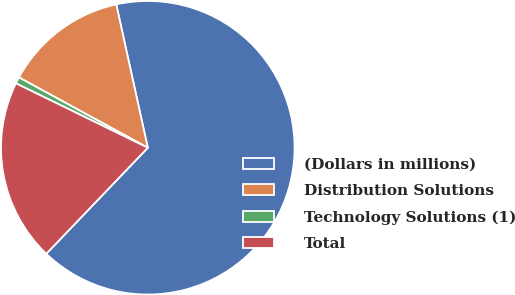Convert chart. <chart><loc_0><loc_0><loc_500><loc_500><pie_chart><fcel>(Dollars in millions)<fcel>Distribution Solutions<fcel>Technology Solutions (1)<fcel>Total<nl><fcel>65.6%<fcel>13.6%<fcel>0.72%<fcel>20.08%<nl></chart> 